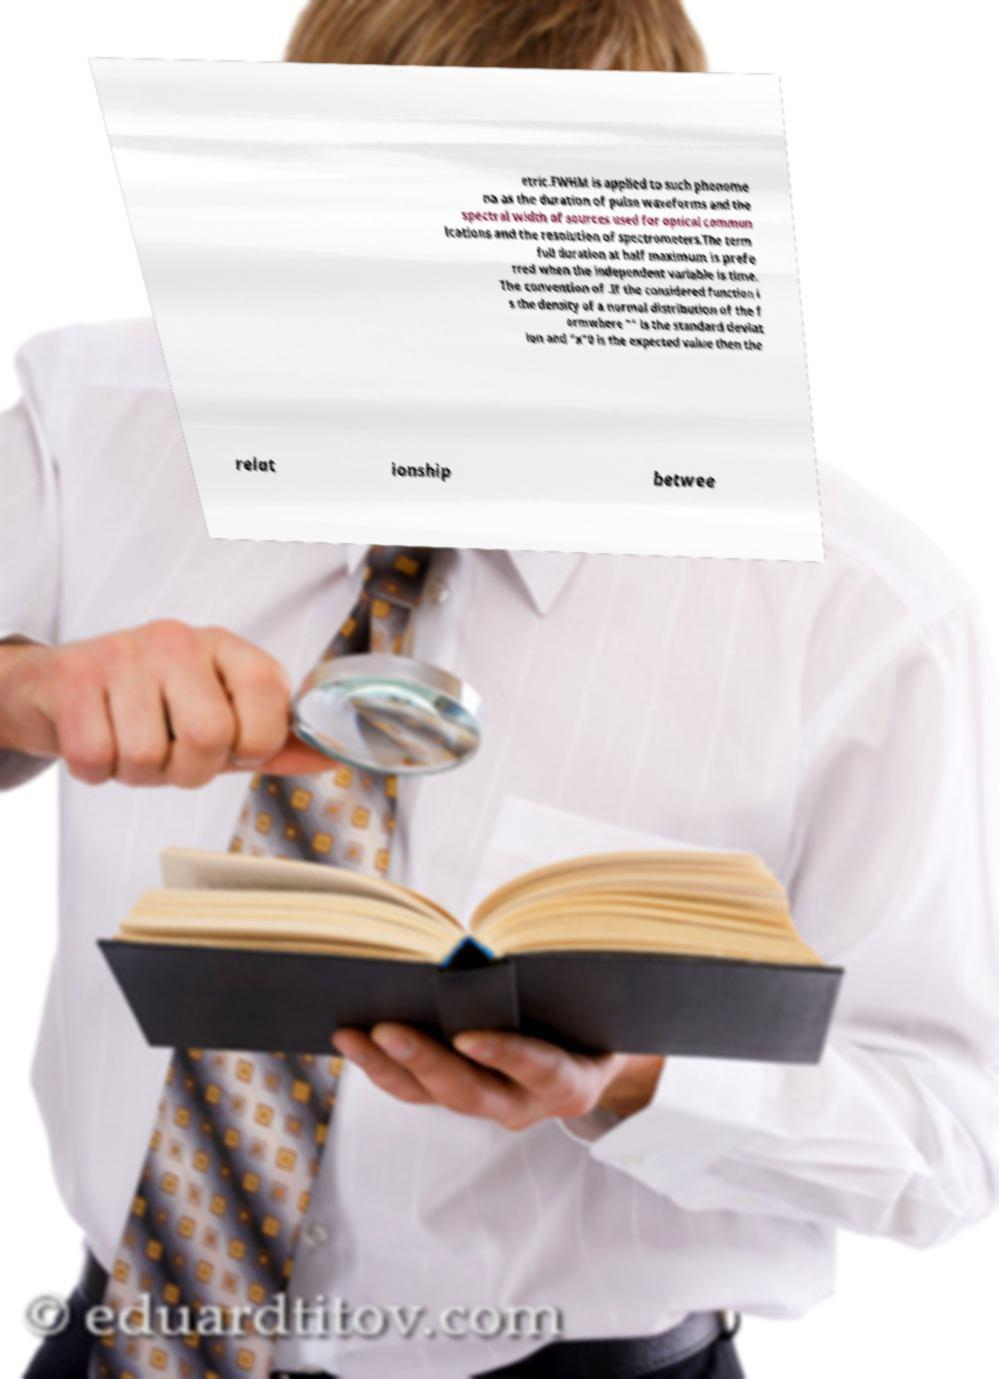Could you extract and type out the text from this image? etric.FWHM is applied to such phenome na as the duration of pulse waveforms and the spectral width of sources used for optical commun ications and the resolution of spectrometers.The term full duration at half maximum is prefe rred when the independent variable is time. The convention of .If the considered function i s the density of a normal distribution of the f ormwhere "" is the standard deviat ion and "x"0 is the expected value then the relat ionship betwee 